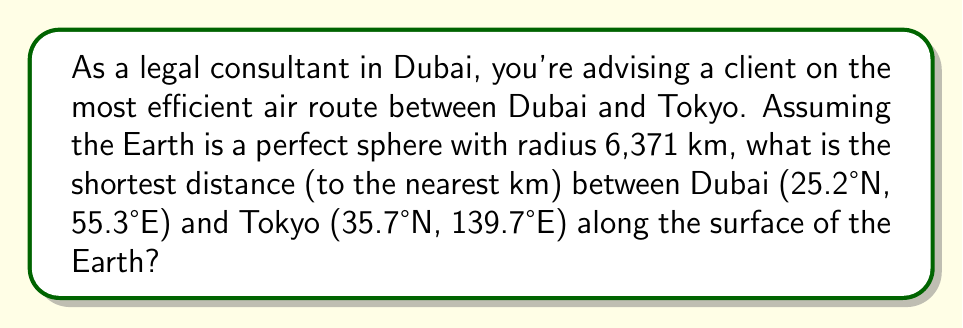Provide a solution to this math problem. To solve this problem, we'll use the great circle distance formula on a sphere:

1) Convert the coordinates to radians:
   Dubai: $\phi_1 = 25.2° \cdot \frac{\pi}{180} = 0.4398$ rad, $\lambda_1 = 55.3° \cdot \frac{\pi}{180} = 0.9651$ rad
   Tokyo: $\phi_2 = 35.7° \cdot \frac{\pi}{180} = 0.6230$ rad, $\lambda_2 = 139.7° \cdot \frac{\pi}{180} = 2.4383$ rad

2) Calculate the central angle $\Delta\sigma$ using the Haversine formula:
   $$\Delta\sigma = 2 \arcsin\left(\sqrt{\sin^2\left(\frac{\phi_2 - \phi_1}{2}\right) + \cos\phi_1 \cos\phi_2 \sin^2\left(\frac{\lambda_2 - \lambda_1}{2}\right)}\right)$$

3) Substitute the values:
   $$\Delta\sigma = 2 \arcsin\left(\sqrt{\sin^2\left(\frac{0.6230 - 0.4398}{2}\right) + \cos(0.4398) \cos(0.6230) \sin^2\left(\frac{2.4383 - 0.9651}{2}\right)}\right)$$

4) Calculate:
   $$\Delta\sigma = 2 \arcsin(\sqrt{0.0084 + 0.7806 \cdot 0.2930}) = 2 \arcsin(\sqrt{0.2371}) = 2 \arcsin(0.4869) = 0.9738$$

5) The distance $d$ is the arc length:
   $$d = R \cdot \Delta\sigma = 6371 \cdot 0.9738 = 6204.37 \text{ km}$$

6) Rounding to the nearest km:
   $$d \approx 6204 \text{ km}$$
Answer: 6204 km 